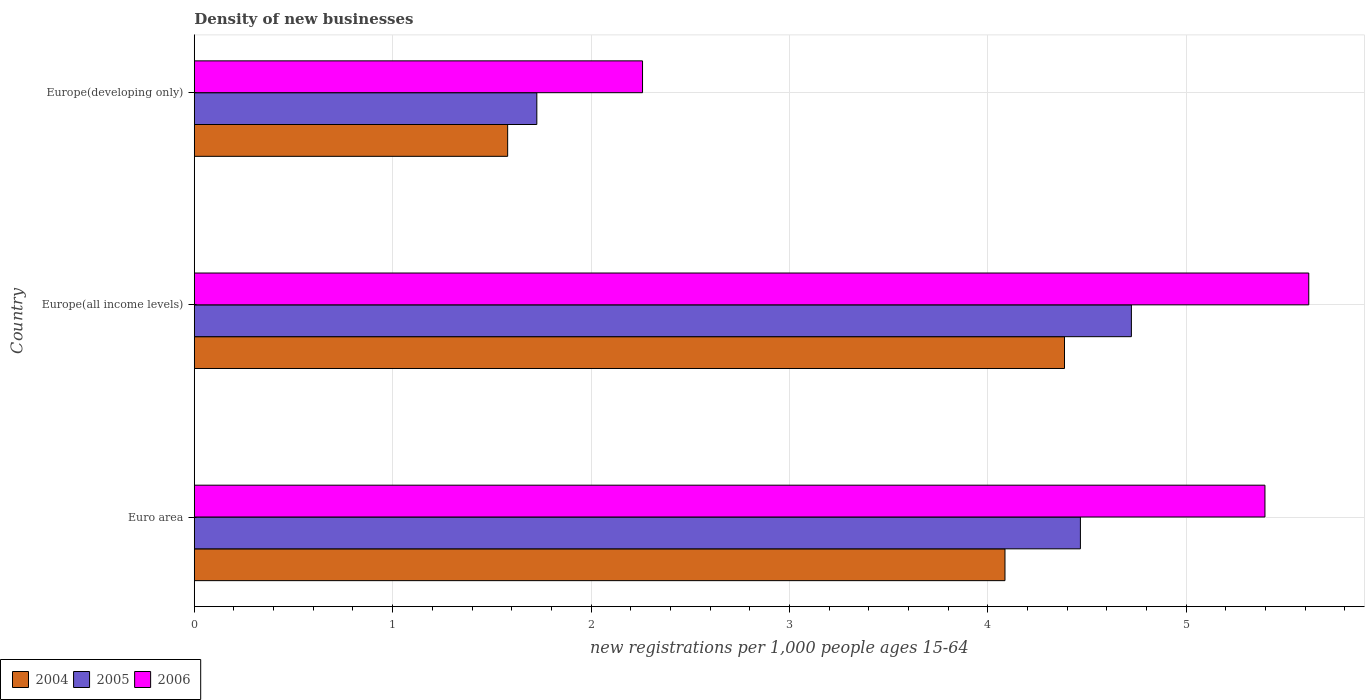How many different coloured bars are there?
Ensure brevity in your answer.  3. How many groups of bars are there?
Keep it short and to the point. 3. Are the number of bars per tick equal to the number of legend labels?
Ensure brevity in your answer.  Yes. How many bars are there on the 1st tick from the top?
Provide a short and direct response. 3. How many bars are there on the 3rd tick from the bottom?
Your answer should be very brief. 3. What is the label of the 2nd group of bars from the top?
Make the answer very short. Europe(all income levels). In how many cases, is the number of bars for a given country not equal to the number of legend labels?
Keep it short and to the point. 0. What is the number of new registrations in 2004 in Europe(all income levels)?
Your answer should be compact. 4.39. Across all countries, what is the maximum number of new registrations in 2005?
Offer a very short reply. 4.72. Across all countries, what is the minimum number of new registrations in 2006?
Offer a terse response. 2.26. In which country was the number of new registrations in 2005 maximum?
Ensure brevity in your answer.  Europe(all income levels). In which country was the number of new registrations in 2004 minimum?
Provide a short and direct response. Europe(developing only). What is the total number of new registrations in 2004 in the graph?
Make the answer very short. 10.05. What is the difference between the number of new registrations in 2006 in Europe(all income levels) and that in Europe(developing only)?
Provide a succinct answer. 3.36. What is the difference between the number of new registrations in 2004 in Europe(all income levels) and the number of new registrations in 2005 in Europe(developing only)?
Provide a short and direct response. 2.66. What is the average number of new registrations in 2005 per country?
Your answer should be very brief. 3.64. What is the difference between the number of new registrations in 2006 and number of new registrations in 2005 in Euro area?
Ensure brevity in your answer.  0.93. In how many countries, is the number of new registrations in 2006 greater than 1.8 ?
Give a very brief answer. 3. What is the ratio of the number of new registrations in 2004 in Euro area to that in Europe(all income levels)?
Give a very brief answer. 0.93. Is the number of new registrations in 2004 in Europe(all income levels) less than that in Europe(developing only)?
Ensure brevity in your answer.  No. What is the difference between the highest and the second highest number of new registrations in 2006?
Offer a very short reply. 0.22. What is the difference between the highest and the lowest number of new registrations in 2005?
Keep it short and to the point. 3. In how many countries, is the number of new registrations in 2005 greater than the average number of new registrations in 2005 taken over all countries?
Offer a terse response. 2. Is the sum of the number of new registrations in 2006 in Euro area and Europe(all income levels) greater than the maximum number of new registrations in 2005 across all countries?
Offer a very short reply. Yes. What does the 3rd bar from the top in Euro area represents?
Give a very brief answer. 2004. How many bars are there?
Keep it short and to the point. 9. What is the difference between two consecutive major ticks on the X-axis?
Your answer should be compact. 1. Does the graph contain any zero values?
Offer a very short reply. No. How many legend labels are there?
Offer a very short reply. 3. How are the legend labels stacked?
Offer a terse response. Horizontal. What is the title of the graph?
Ensure brevity in your answer.  Density of new businesses. Does "2000" appear as one of the legend labels in the graph?
Give a very brief answer. No. What is the label or title of the X-axis?
Your answer should be very brief. New registrations per 1,0 people ages 15-64. What is the label or title of the Y-axis?
Keep it short and to the point. Country. What is the new registrations per 1,000 people ages 15-64 in 2004 in Euro area?
Offer a terse response. 4.09. What is the new registrations per 1,000 people ages 15-64 in 2005 in Euro area?
Offer a terse response. 4.47. What is the new registrations per 1,000 people ages 15-64 of 2006 in Euro area?
Your response must be concise. 5.4. What is the new registrations per 1,000 people ages 15-64 of 2004 in Europe(all income levels)?
Provide a short and direct response. 4.39. What is the new registrations per 1,000 people ages 15-64 in 2005 in Europe(all income levels)?
Provide a succinct answer. 4.72. What is the new registrations per 1,000 people ages 15-64 in 2006 in Europe(all income levels)?
Your answer should be compact. 5.62. What is the new registrations per 1,000 people ages 15-64 of 2004 in Europe(developing only)?
Ensure brevity in your answer.  1.58. What is the new registrations per 1,000 people ages 15-64 of 2005 in Europe(developing only)?
Keep it short and to the point. 1.73. What is the new registrations per 1,000 people ages 15-64 of 2006 in Europe(developing only)?
Keep it short and to the point. 2.26. Across all countries, what is the maximum new registrations per 1,000 people ages 15-64 of 2004?
Provide a succinct answer. 4.39. Across all countries, what is the maximum new registrations per 1,000 people ages 15-64 in 2005?
Make the answer very short. 4.72. Across all countries, what is the maximum new registrations per 1,000 people ages 15-64 of 2006?
Make the answer very short. 5.62. Across all countries, what is the minimum new registrations per 1,000 people ages 15-64 of 2004?
Your answer should be very brief. 1.58. Across all countries, what is the minimum new registrations per 1,000 people ages 15-64 of 2005?
Offer a terse response. 1.73. Across all countries, what is the minimum new registrations per 1,000 people ages 15-64 in 2006?
Your answer should be compact. 2.26. What is the total new registrations per 1,000 people ages 15-64 in 2004 in the graph?
Provide a succinct answer. 10.05. What is the total new registrations per 1,000 people ages 15-64 in 2005 in the graph?
Your answer should be compact. 10.92. What is the total new registrations per 1,000 people ages 15-64 of 2006 in the graph?
Keep it short and to the point. 13.27. What is the difference between the new registrations per 1,000 people ages 15-64 of 2004 in Euro area and that in Europe(all income levels)?
Offer a terse response. -0.3. What is the difference between the new registrations per 1,000 people ages 15-64 in 2005 in Euro area and that in Europe(all income levels)?
Keep it short and to the point. -0.26. What is the difference between the new registrations per 1,000 people ages 15-64 in 2006 in Euro area and that in Europe(all income levels)?
Offer a terse response. -0.22. What is the difference between the new registrations per 1,000 people ages 15-64 in 2004 in Euro area and that in Europe(developing only)?
Offer a very short reply. 2.51. What is the difference between the new registrations per 1,000 people ages 15-64 of 2005 in Euro area and that in Europe(developing only)?
Provide a succinct answer. 2.74. What is the difference between the new registrations per 1,000 people ages 15-64 in 2006 in Euro area and that in Europe(developing only)?
Provide a succinct answer. 3.14. What is the difference between the new registrations per 1,000 people ages 15-64 of 2004 in Europe(all income levels) and that in Europe(developing only)?
Offer a terse response. 2.81. What is the difference between the new registrations per 1,000 people ages 15-64 of 2005 in Europe(all income levels) and that in Europe(developing only)?
Your answer should be very brief. 3. What is the difference between the new registrations per 1,000 people ages 15-64 of 2006 in Europe(all income levels) and that in Europe(developing only)?
Your answer should be very brief. 3.36. What is the difference between the new registrations per 1,000 people ages 15-64 of 2004 in Euro area and the new registrations per 1,000 people ages 15-64 of 2005 in Europe(all income levels)?
Keep it short and to the point. -0.64. What is the difference between the new registrations per 1,000 people ages 15-64 of 2004 in Euro area and the new registrations per 1,000 people ages 15-64 of 2006 in Europe(all income levels)?
Make the answer very short. -1.53. What is the difference between the new registrations per 1,000 people ages 15-64 of 2005 in Euro area and the new registrations per 1,000 people ages 15-64 of 2006 in Europe(all income levels)?
Keep it short and to the point. -1.15. What is the difference between the new registrations per 1,000 people ages 15-64 in 2004 in Euro area and the new registrations per 1,000 people ages 15-64 in 2005 in Europe(developing only)?
Your answer should be compact. 2.36. What is the difference between the new registrations per 1,000 people ages 15-64 of 2004 in Euro area and the new registrations per 1,000 people ages 15-64 of 2006 in Europe(developing only)?
Offer a very short reply. 1.83. What is the difference between the new registrations per 1,000 people ages 15-64 in 2005 in Euro area and the new registrations per 1,000 people ages 15-64 in 2006 in Europe(developing only)?
Provide a succinct answer. 2.21. What is the difference between the new registrations per 1,000 people ages 15-64 of 2004 in Europe(all income levels) and the new registrations per 1,000 people ages 15-64 of 2005 in Europe(developing only)?
Keep it short and to the point. 2.66. What is the difference between the new registrations per 1,000 people ages 15-64 of 2004 in Europe(all income levels) and the new registrations per 1,000 people ages 15-64 of 2006 in Europe(developing only)?
Your answer should be very brief. 2.13. What is the difference between the new registrations per 1,000 people ages 15-64 of 2005 in Europe(all income levels) and the new registrations per 1,000 people ages 15-64 of 2006 in Europe(developing only)?
Your answer should be compact. 2.46. What is the average new registrations per 1,000 people ages 15-64 in 2004 per country?
Ensure brevity in your answer.  3.35. What is the average new registrations per 1,000 people ages 15-64 in 2005 per country?
Make the answer very short. 3.64. What is the average new registrations per 1,000 people ages 15-64 in 2006 per country?
Ensure brevity in your answer.  4.42. What is the difference between the new registrations per 1,000 people ages 15-64 in 2004 and new registrations per 1,000 people ages 15-64 in 2005 in Euro area?
Provide a short and direct response. -0.38. What is the difference between the new registrations per 1,000 people ages 15-64 of 2004 and new registrations per 1,000 people ages 15-64 of 2006 in Euro area?
Your response must be concise. -1.31. What is the difference between the new registrations per 1,000 people ages 15-64 of 2005 and new registrations per 1,000 people ages 15-64 of 2006 in Euro area?
Make the answer very short. -0.93. What is the difference between the new registrations per 1,000 people ages 15-64 in 2004 and new registrations per 1,000 people ages 15-64 in 2005 in Europe(all income levels)?
Your answer should be compact. -0.34. What is the difference between the new registrations per 1,000 people ages 15-64 in 2004 and new registrations per 1,000 people ages 15-64 in 2006 in Europe(all income levels)?
Make the answer very short. -1.23. What is the difference between the new registrations per 1,000 people ages 15-64 of 2005 and new registrations per 1,000 people ages 15-64 of 2006 in Europe(all income levels)?
Provide a short and direct response. -0.89. What is the difference between the new registrations per 1,000 people ages 15-64 of 2004 and new registrations per 1,000 people ages 15-64 of 2005 in Europe(developing only)?
Offer a terse response. -0.15. What is the difference between the new registrations per 1,000 people ages 15-64 of 2004 and new registrations per 1,000 people ages 15-64 of 2006 in Europe(developing only)?
Provide a succinct answer. -0.68. What is the difference between the new registrations per 1,000 people ages 15-64 in 2005 and new registrations per 1,000 people ages 15-64 in 2006 in Europe(developing only)?
Offer a terse response. -0.53. What is the ratio of the new registrations per 1,000 people ages 15-64 in 2004 in Euro area to that in Europe(all income levels)?
Give a very brief answer. 0.93. What is the ratio of the new registrations per 1,000 people ages 15-64 in 2005 in Euro area to that in Europe(all income levels)?
Provide a short and direct response. 0.95. What is the ratio of the new registrations per 1,000 people ages 15-64 in 2006 in Euro area to that in Europe(all income levels)?
Your answer should be compact. 0.96. What is the ratio of the new registrations per 1,000 people ages 15-64 of 2004 in Euro area to that in Europe(developing only)?
Keep it short and to the point. 2.59. What is the ratio of the new registrations per 1,000 people ages 15-64 in 2005 in Euro area to that in Europe(developing only)?
Keep it short and to the point. 2.59. What is the ratio of the new registrations per 1,000 people ages 15-64 of 2006 in Euro area to that in Europe(developing only)?
Your answer should be compact. 2.39. What is the ratio of the new registrations per 1,000 people ages 15-64 in 2004 in Europe(all income levels) to that in Europe(developing only)?
Give a very brief answer. 2.78. What is the ratio of the new registrations per 1,000 people ages 15-64 in 2005 in Europe(all income levels) to that in Europe(developing only)?
Provide a short and direct response. 2.74. What is the ratio of the new registrations per 1,000 people ages 15-64 in 2006 in Europe(all income levels) to that in Europe(developing only)?
Provide a succinct answer. 2.49. What is the difference between the highest and the second highest new registrations per 1,000 people ages 15-64 in 2004?
Ensure brevity in your answer.  0.3. What is the difference between the highest and the second highest new registrations per 1,000 people ages 15-64 in 2005?
Your answer should be very brief. 0.26. What is the difference between the highest and the second highest new registrations per 1,000 people ages 15-64 in 2006?
Provide a succinct answer. 0.22. What is the difference between the highest and the lowest new registrations per 1,000 people ages 15-64 of 2004?
Your response must be concise. 2.81. What is the difference between the highest and the lowest new registrations per 1,000 people ages 15-64 of 2005?
Provide a short and direct response. 3. What is the difference between the highest and the lowest new registrations per 1,000 people ages 15-64 in 2006?
Offer a terse response. 3.36. 